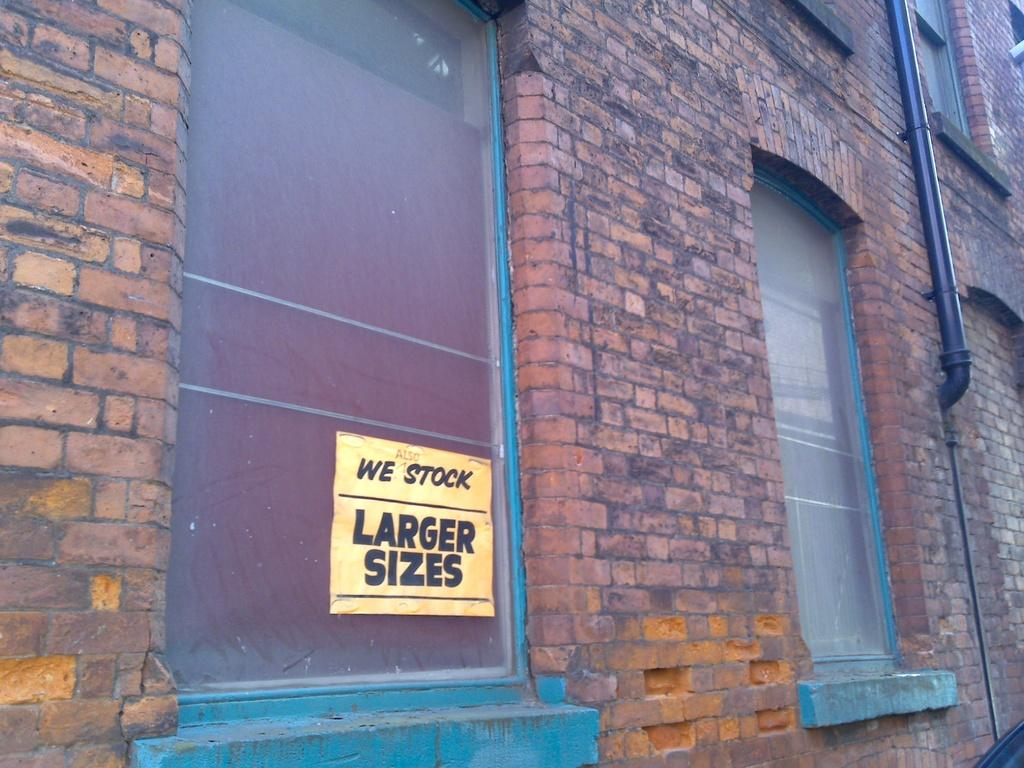What is the main structure in the picture? There is a building in the picture. What features can be observed on the building? The building has windows and a pipe. Can you describe the yellow object in the picture? The yellow object has something written on it. How many dogs are accompanying the person on their journey in the image? There are no dogs or people depicted in the image, and no journey is taking place. 